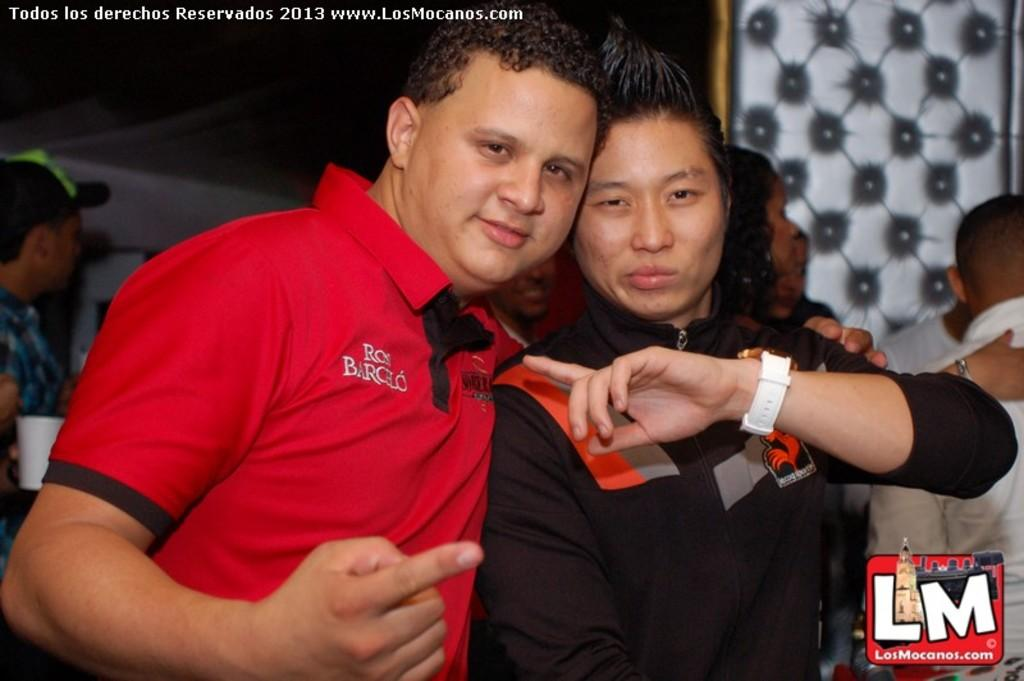What are the colors of the dresses worn by the two main persons in the image? There is a person wearing a red dress and another person wearing a black dress in the image. Can you describe the other persons visible in the image? There are other persons visible behind them. What is the color of the background in the image? The background of the image is dark. Can you see a wren perched on the shoulder of the person wearing the red dress in the image? There is no wren present in the image. 